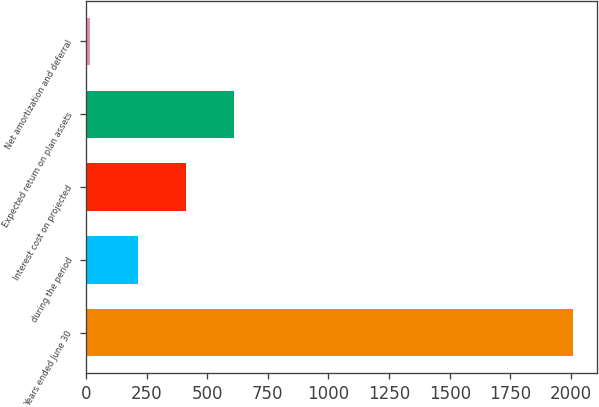Convert chart. <chart><loc_0><loc_0><loc_500><loc_500><bar_chart><fcel>Years ended June 30<fcel>during the period<fcel>Interest cost on projected<fcel>Expected return on plan assets<fcel>Net amortization and deferral<nl><fcel>2007<fcel>213.84<fcel>413.08<fcel>612.32<fcel>14.6<nl></chart> 